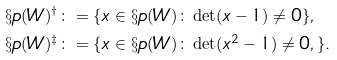<formula> <loc_0><loc_0><loc_500><loc_500>\S p ( W ) ^ { \dagger } & \colon = \{ x \in \S p ( W ) \colon \det ( x - 1 ) \neq 0 \} , \\ \S p ( W ) ^ { \ddagger } & \colon = \{ x \in \S p ( W ) \colon \det ( x ^ { 2 } - 1 ) \neq 0 , \} .</formula> 